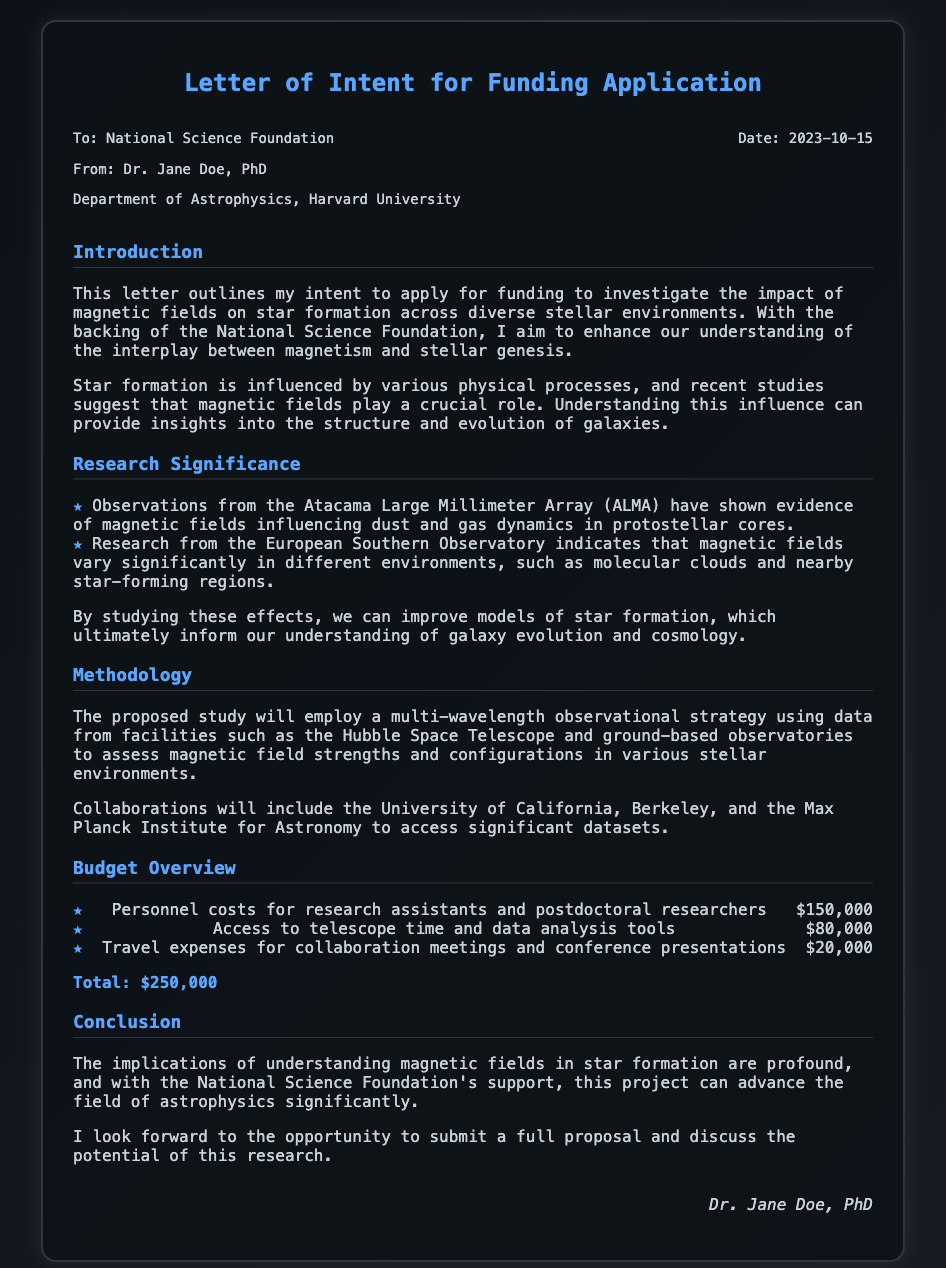What is the date of the letter? The date of the letter is specified in the header information of the document.
Answer: 2023-10-15 Who is the principal investigator? The name of the principal investigator is mentioned at the beginning of the document.
Answer: Dr. Jane Doe What is the total budget requested? The total budget is calculated and mentioned in the budget overview section.
Answer: $250,000 What astronomical facility provides data according to the methodology? The document lists facilities involved in the proposed study.
Answer: Hubble Space Telescope What is one significance of studying magnetic fields mentioned in the document? The document describes the impact of magnetic fields on specific aspects of star formation.
Answer: Galaxy evolution Which two institutions will collaborate on this research? Collaborating institutions are explicitly named in the methodology section.
Answer: University of California, Berkeley and Max Planck Institute for Astronomy What type of observational strategy will be employed? The methodology provides insight into the strategy for data gathering.
Answer: Multi-wavelength observational strategy What is the first item listed in the budget overview? The budget overview outlines various financial requirements for the project.
Answer: Personnel costs for research assistants and postdoctoral researchers What is the research's goal mentioned in the introduction? The introduction outlines the main aim of the research project.
Answer: Investigate the impact of magnetic fields on star formation 